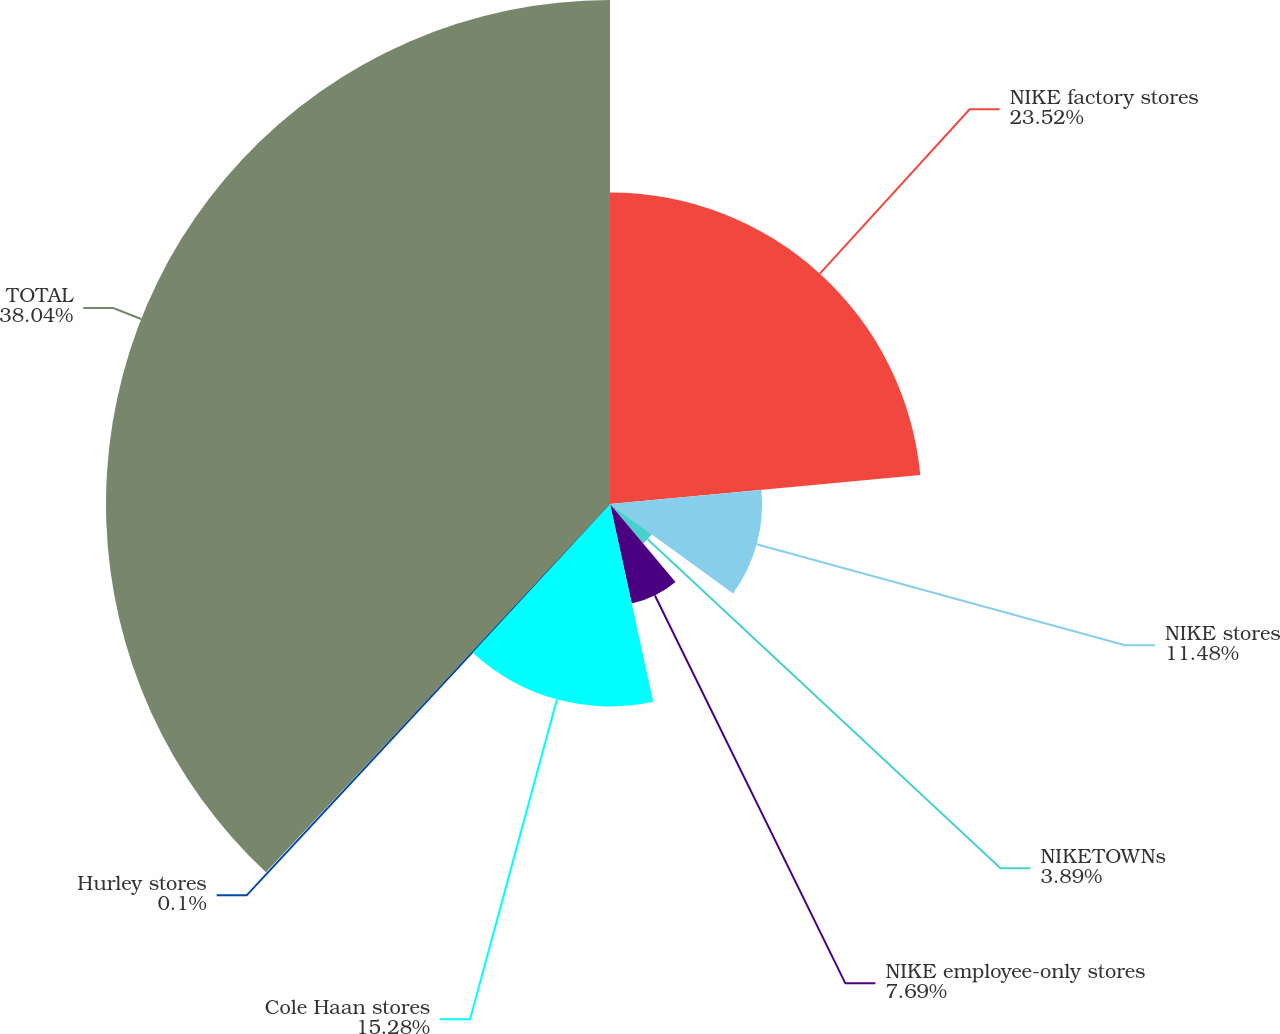Convert chart to OTSL. <chart><loc_0><loc_0><loc_500><loc_500><pie_chart><fcel>NIKE factory stores<fcel>NIKE stores<fcel>NIKETOWNs<fcel>NIKE employee-only stores<fcel>Cole Haan stores<fcel>Hurley stores<fcel>TOTAL<nl><fcel>23.52%<fcel>11.48%<fcel>3.89%<fcel>7.69%<fcel>15.28%<fcel>0.1%<fcel>38.04%<nl></chart> 